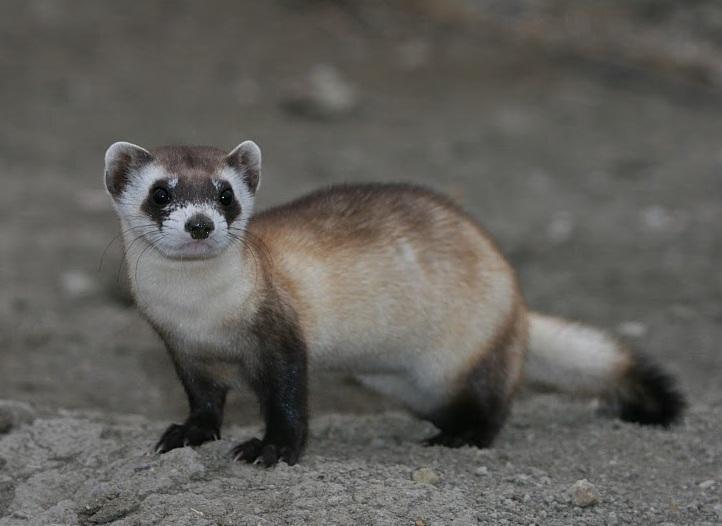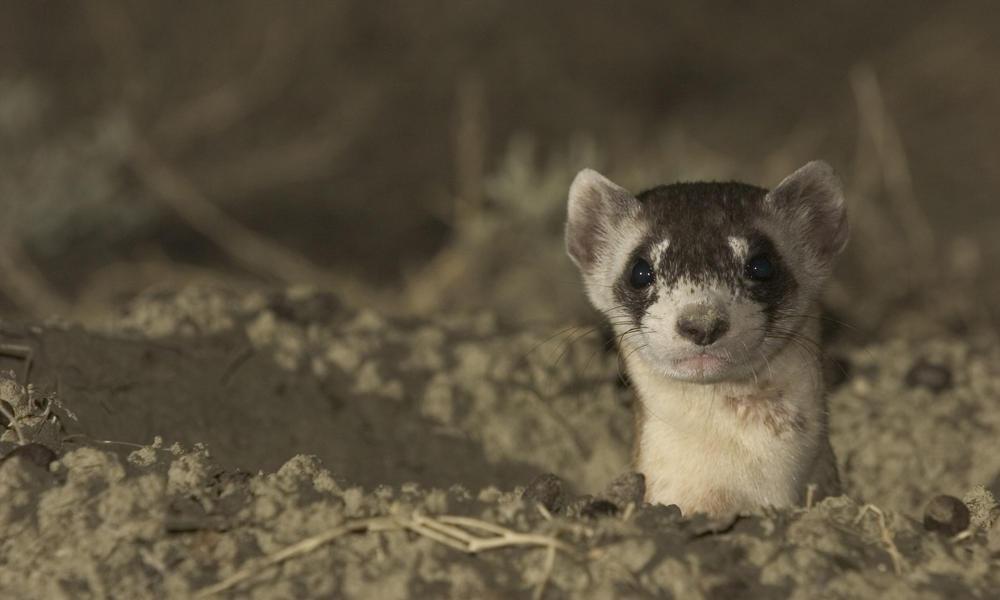The first image is the image on the left, the second image is the image on the right. Examine the images to the left and right. Is the description "there are five animals in the image on the left" accurate? Answer yes or no. No. The first image is the image on the left, the second image is the image on the right. Examine the images to the left and right. Is the description "An image contains a row of five ferrets." accurate? Answer yes or no. No. 